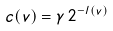Convert formula to latex. <formula><loc_0><loc_0><loc_500><loc_500>c ( v ) = \gamma \, 2 ^ { - l ( v ) }</formula> 